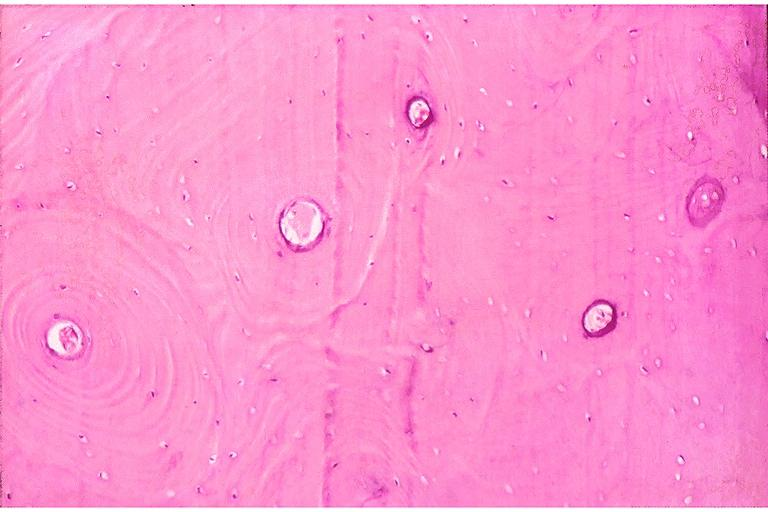what is present?
Answer the question using a single word or phrase. Oral 